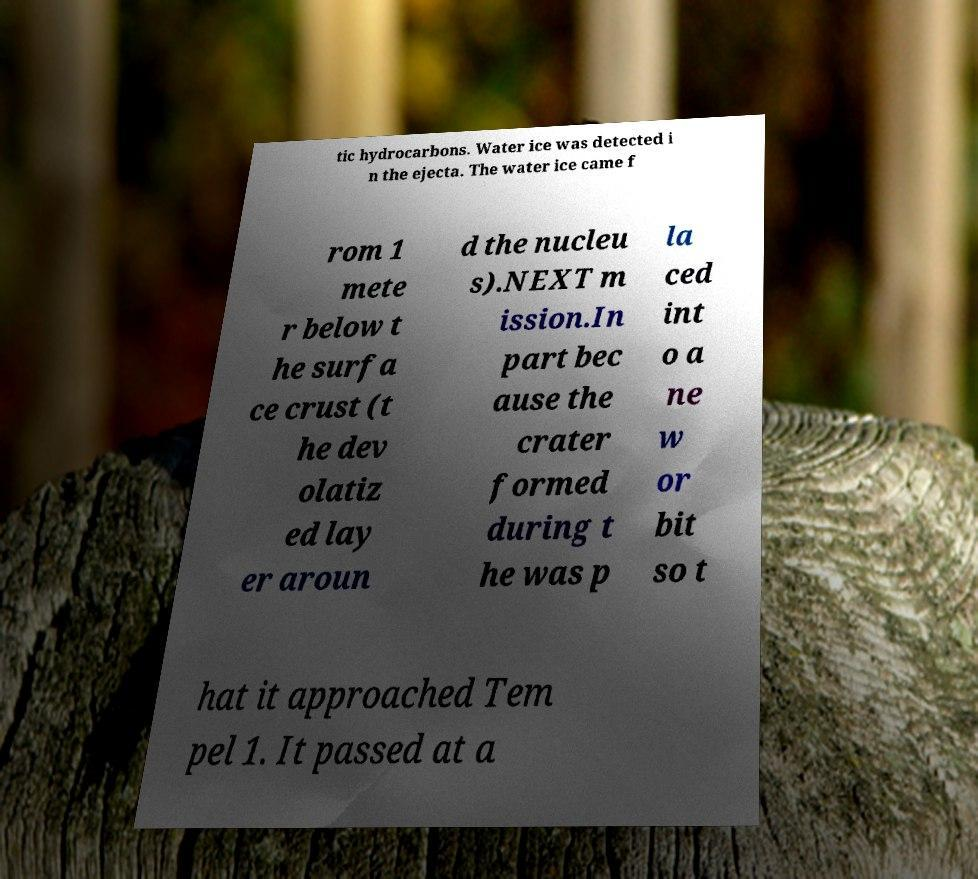What messages or text are displayed in this image? I need them in a readable, typed format. tic hydrocarbons. Water ice was detected i n the ejecta. The water ice came f rom 1 mete r below t he surfa ce crust (t he dev olatiz ed lay er aroun d the nucleu s).NEXT m ission.In part bec ause the crater formed during t he was p la ced int o a ne w or bit so t hat it approached Tem pel 1. It passed at a 